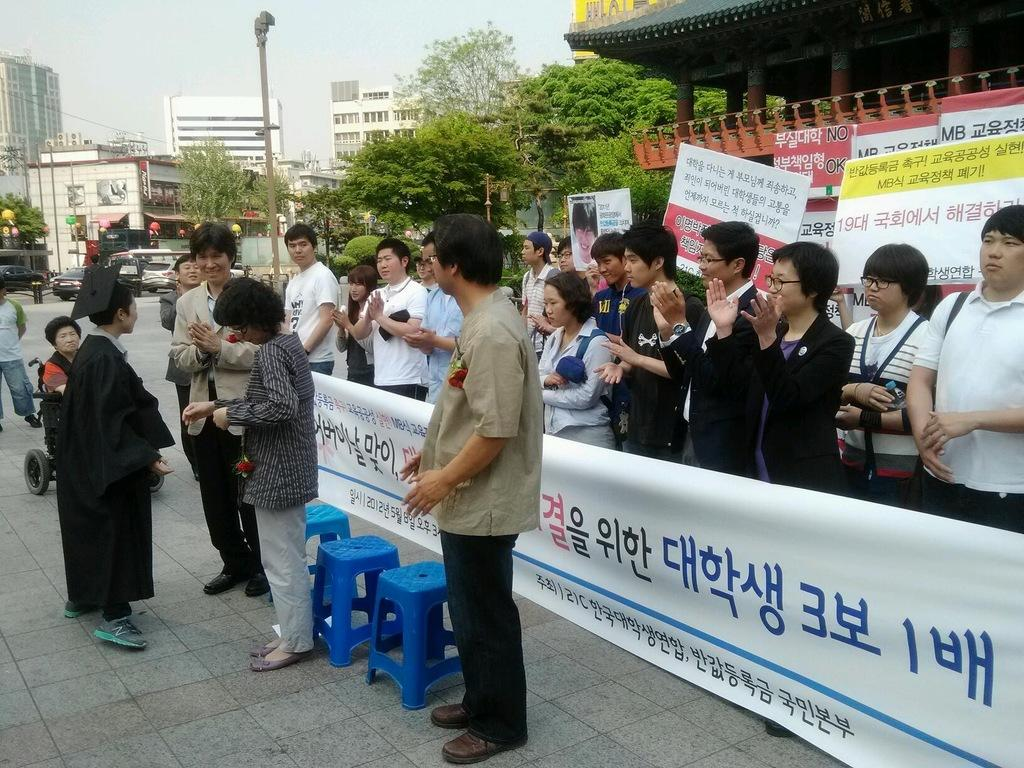What can be seen in the image involving human presence? There are people standing in the image. What type of natural elements are present in the image? There are trees in the image. What type of man-made structures can be seen in the image? There are buildings in the image. What type of furniture is visible in the image? There are stools in the image. What type of decorative items are present in the image? There are posters in the image. What part of the natural environment is visible in the image? The sky is visible in the image. What type of calendar is hanging on the wall in the image? There is no calendar present in the image. Can you tell me how many grandmothers are visible in the image? There is no grandmother present in the image. 